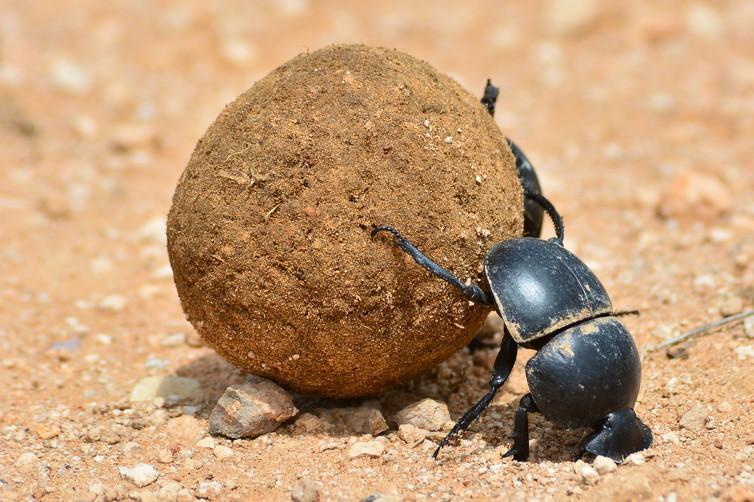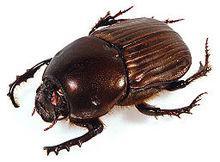The first image is the image on the left, the second image is the image on the right. Given the left and right images, does the statement "There is more than four beetles." hold true? Answer yes or no. No. 